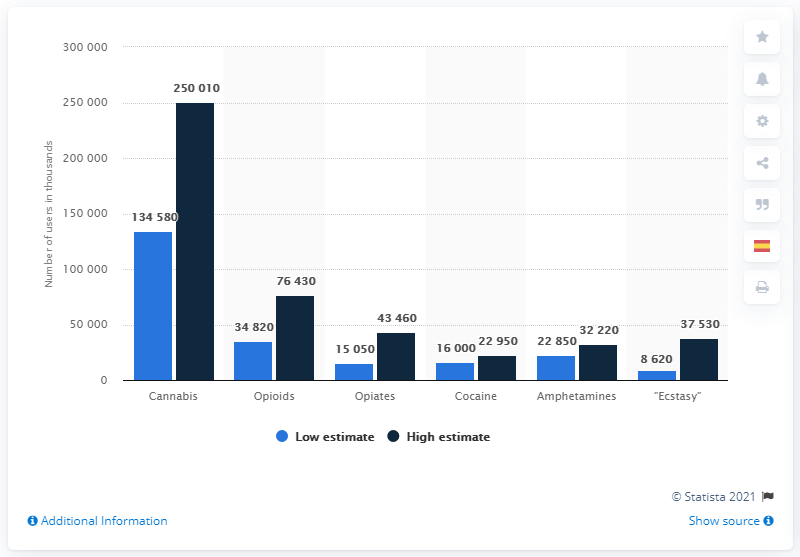Point out several critical features in this image. In 2018, it is estimated that there were approximately 348,200 individuals worldwide who were current opioid users. 